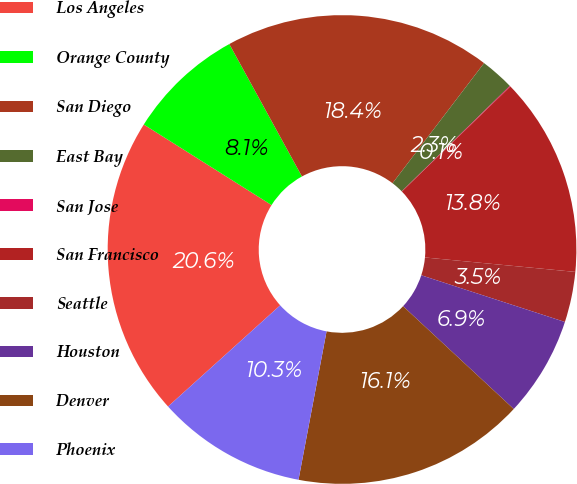<chart> <loc_0><loc_0><loc_500><loc_500><pie_chart><fcel>Los Angeles<fcel>Orange County<fcel>San Diego<fcel>East Bay<fcel>San Jose<fcel>San Francisco<fcel>Seattle<fcel>Houston<fcel>Denver<fcel>Phoenix<nl><fcel>20.64%<fcel>8.06%<fcel>18.35%<fcel>2.34%<fcel>0.05%<fcel>13.77%<fcel>3.48%<fcel>6.91%<fcel>16.06%<fcel>10.34%<nl></chart> 